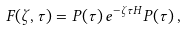Convert formula to latex. <formula><loc_0><loc_0><loc_500><loc_500>F ( \zeta , \tau ) = P ( \tau ) \, e ^ { - \zeta \tau H } P ( \tau ) \, ,</formula> 